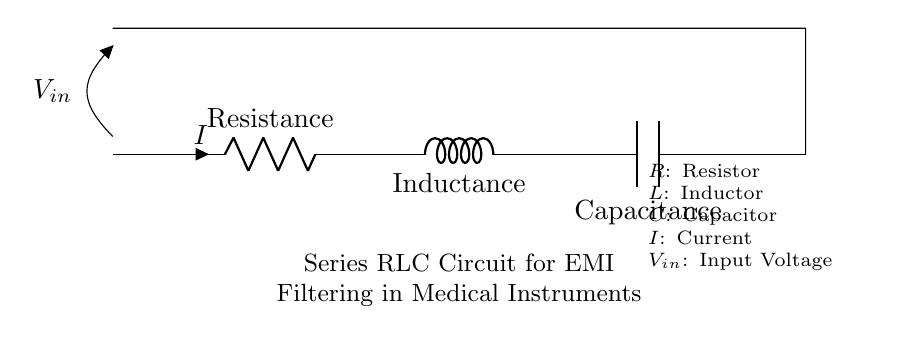What are the components in this circuit? The circuit consists of three main components: a resistor, an inductor, and a capacitor. These are indicated by the labels R, L, and C in the diagram.
Answer: Resistor, Inductor, Capacitor What is the role of the resistor in this circuit? The resistor in the circuit primarily serves to limit the current flowing through the circuit, helping to attenuate high-frequency noise and provide a stable reference for voltage.
Answer: Limit current What is the total impedance of a series RLC circuit? The total impedance in a series RLC circuit is the vector sum of the resistance, inductive reactance, and capacitive reactance. This relationship shows that the impedance varies depending on the frequency of the input signal.
Answer: Vector sum of R, L, and C What type of filtering does this circuit provide? This circuit provides low-pass filtering characteristics, allowing low-frequency signals to pass while attenuating higher frequency electromagnetic interference.
Answer: Low-pass filtering What happens to the input voltage when the circuit is operating at resonance? At resonance, the impedance of the circuit is minimized, causing the input voltage to be maximum across the components, allowing for efficient energy transfer at the resonant frequency.
Answer: Maximum input voltage How does the arrangement of components affect frequency response? The arrangement of the resistor, inductor, and capacitor in series defines the specific resonant frequency of the circuit, influencing the frequency response by defining bandwidth and cutoff frequency.
Answer: Affects resonant frequency What is the significance of using a series RLC circuit in medical instruments? The use of a series RLC circuit in medical instruments is significant because it helps reduce electromagnetic interference, which can affect the accuracy and reliability of sensitive medical measurements and devices.
Answer: Reduces electromagnetic interference 